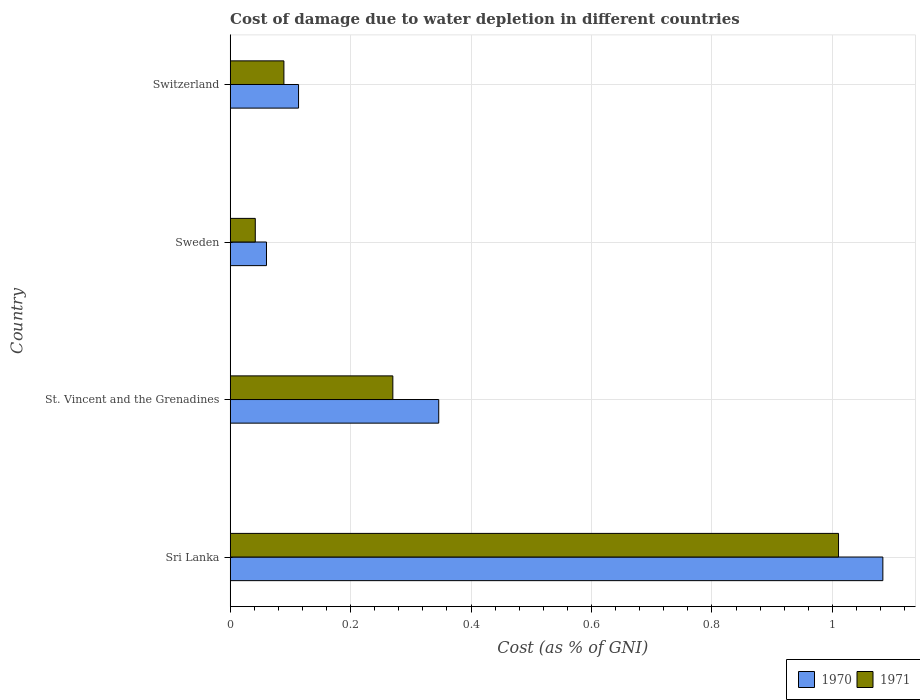How many groups of bars are there?
Offer a very short reply. 4. Are the number of bars per tick equal to the number of legend labels?
Ensure brevity in your answer.  Yes. Are the number of bars on each tick of the Y-axis equal?
Ensure brevity in your answer.  Yes. How many bars are there on the 2nd tick from the top?
Your answer should be very brief. 2. What is the label of the 4th group of bars from the top?
Your answer should be very brief. Sri Lanka. In how many cases, is the number of bars for a given country not equal to the number of legend labels?
Ensure brevity in your answer.  0. What is the cost of damage caused due to water depletion in 1971 in Sweden?
Your response must be concise. 0.04. Across all countries, what is the maximum cost of damage caused due to water depletion in 1970?
Give a very brief answer. 1.08. Across all countries, what is the minimum cost of damage caused due to water depletion in 1971?
Provide a short and direct response. 0.04. In which country was the cost of damage caused due to water depletion in 1970 maximum?
Keep it short and to the point. Sri Lanka. In which country was the cost of damage caused due to water depletion in 1971 minimum?
Make the answer very short. Sweden. What is the total cost of damage caused due to water depletion in 1970 in the graph?
Your response must be concise. 1.6. What is the difference between the cost of damage caused due to water depletion in 1971 in St. Vincent and the Grenadines and that in Switzerland?
Keep it short and to the point. 0.18. What is the difference between the cost of damage caused due to water depletion in 1970 in Switzerland and the cost of damage caused due to water depletion in 1971 in Sweden?
Give a very brief answer. 0.07. What is the average cost of damage caused due to water depletion in 1971 per country?
Your answer should be compact. 0.35. What is the difference between the cost of damage caused due to water depletion in 1970 and cost of damage caused due to water depletion in 1971 in Sweden?
Ensure brevity in your answer.  0.02. What is the ratio of the cost of damage caused due to water depletion in 1971 in Sri Lanka to that in Sweden?
Offer a terse response. 24.24. Is the cost of damage caused due to water depletion in 1971 in Sri Lanka less than that in Switzerland?
Offer a terse response. No. Is the difference between the cost of damage caused due to water depletion in 1970 in Sri Lanka and St. Vincent and the Grenadines greater than the difference between the cost of damage caused due to water depletion in 1971 in Sri Lanka and St. Vincent and the Grenadines?
Provide a succinct answer. No. What is the difference between the highest and the second highest cost of damage caused due to water depletion in 1970?
Give a very brief answer. 0.74. What is the difference between the highest and the lowest cost of damage caused due to water depletion in 1971?
Provide a short and direct response. 0.97. In how many countries, is the cost of damage caused due to water depletion in 1970 greater than the average cost of damage caused due to water depletion in 1970 taken over all countries?
Your answer should be very brief. 1. Is the sum of the cost of damage caused due to water depletion in 1970 in Sweden and Switzerland greater than the maximum cost of damage caused due to water depletion in 1971 across all countries?
Make the answer very short. No. What does the 1st bar from the top in Sweden represents?
Provide a succinct answer. 1971. How many bars are there?
Provide a succinct answer. 8. How many countries are there in the graph?
Your answer should be very brief. 4. What is the difference between two consecutive major ticks on the X-axis?
Keep it short and to the point. 0.2. Are the values on the major ticks of X-axis written in scientific E-notation?
Your answer should be compact. No. Does the graph contain grids?
Keep it short and to the point. Yes. How many legend labels are there?
Your response must be concise. 2. How are the legend labels stacked?
Make the answer very short. Horizontal. What is the title of the graph?
Keep it short and to the point. Cost of damage due to water depletion in different countries. Does "1972" appear as one of the legend labels in the graph?
Provide a short and direct response. No. What is the label or title of the X-axis?
Your answer should be very brief. Cost (as % of GNI). What is the label or title of the Y-axis?
Give a very brief answer. Country. What is the Cost (as % of GNI) in 1970 in Sri Lanka?
Offer a terse response. 1.08. What is the Cost (as % of GNI) of 1971 in Sri Lanka?
Your answer should be compact. 1.01. What is the Cost (as % of GNI) in 1970 in St. Vincent and the Grenadines?
Offer a terse response. 0.35. What is the Cost (as % of GNI) in 1971 in St. Vincent and the Grenadines?
Your answer should be compact. 0.27. What is the Cost (as % of GNI) in 1970 in Sweden?
Keep it short and to the point. 0.06. What is the Cost (as % of GNI) of 1971 in Sweden?
Give a very brief answer. 0.04. What is the Cost (as % of GNI) in 1970 in Switzerland?
Offer a very short reply. 0.11. What is the Cost (as % of GNI) in 1971 in Switzerland?
Your answer should be very brief. 0.09. Across all countries, what is the maximum Cost (as % of GNI) in 1970?
Make the answer very short. 1.08. Across all countries, what is the maximum Cost (as % of GNI) in 1971?
Your answer should be compact. 1.01. Across all countries, what is the minimum Cost (as % of GNI) in 1970?
Provide a short and direct response. 0.06. Across all countries, what is the minimum Cost (as % of GNI) of 1971?
Your response must be concise. 0.04. What is the total Cost (as % of GNI) of 1970 in the graph?
Your answer should be very brief. 1.6. What is the total Cost (as % of GNI) in 1971 in the graph?
Offer a terse response. 1.41. What is the difference between the Cost (as % of GNI) of 1970 in Sri Lanka and that in St. Vincent and the Grenadines?
Give a very brief answer. 0.74. What is the difference between the Cost (as % of GNI) of 1971 in Sri Lanka and that in St. Vincent and the Grenadines?
Give a very brief answer. 0.74. What is the difference between the Cost (as % of GNI) in 1970 in Sri Lanka and that in Sweden?
Ensure brevity in your answer.  1.02. What is the difference between the Cost (as % of GNI) of 1971 in Sri Lanka and that in Sweden?
Make the answer very short. 0.97. What is the difference between the Cost (as % of GNI) in 1970 in Sri Lanka and that in Switzerland?
Your response must be concise. 0.97. What is the difference between the Cost (as % of GNI) of 1971 in Sri Lanka and that in Switzerland?
Give a very brief answer. 0.92. What is the difference between the Cost (as % of GNI) of 1970 in St. Vincent and the Grenadines and that in Sweden?
Ensure brevity in your answer.  0.29. What is the difference between the Cost (as % of GNI) of 1971 in St. Vincent and the Grenadines and that in Sweden?
Your response must be concise. 0.23. What is the difference between the Cost (as % of GNI) in 1970 in St. Vincent and the Grenadines and that in Switzerland?
Give a very brief answer. 0.23. What is the difference between the Cost (as % of GNI) in 1971 in St. Vincent and the Grenadines and that in Switzerland?
Keep it short and to the point. 0.18. What is the difference between the Cost (as % of GNI) in 1970 in Sweden and that in Switzerland?
Your answer should be very brief. -0.05. What is the difference between the Cost (as % of GNI) in 1971 in Sweden and that in Switzerland?
Your response must be concise. -0.05. What is the difference between the Cost (as % of GNI) of 1970 in Sri Lanka and the Cost (as % of GNI) of 1971 in St. Vincent and the Grenadines?
Your response must be concise. 0.81. What is the difference between the Cost (as % of GNI) of 1970 in Sri Lanka and the Cost (as % of GNI) of 1971 in Sweden?
Offer a very short reply. 1.04. What is the difference between the Cost (as % of GNI) in 1970 in Sri Lanka and the Cost (as % of GNI) in 1971 in Switzerland?
Provide a short and direct response. 0.99. What is the difference between the Cost (as % of GNI) in 1970 in St. Vincent and the Grenadines and the Cost (as % of GNI) in 1971 in Sweden?
Keep it short and to the point. 0.3. What is the difference between the Cost (as % of GNI) in 1970 in St. Vincent and the Grenadines and the Cost (as % of GNI) in 1971 in Switzerland?
Keep it short and to the point. 0.26. What is the difference between the Cost (as % of GNI) in 1970 in Sweden and the Cost (as % of GNI) in 1971 in Switzerland?
Offer a very short reply. -0.03. What is the average Cost (as % of GNI) in 1970 per country?
Keep it short and to the point. 0.4. What is the average Cost (as % of GNI) in 1971 per country?
Give a very brief answer. 0.35. What is the difference between the Cost (as % of GNI) in 1970 and Cost (as % of GNI) in 1971 in Sri Lanka?
Offer a terse response. 0.07. What is the difference between the Cost (as % of GNI) in 1970 and Cost (as % of GNI) in 1971 in St. Vincent and the Grenadines?
Provide a short and direct response. 0.08. What is the difference between the Cost (as % of GNI) in 1970 and Cost (as % of GNI) in 1971 in Sweden?
Ensure brevity in your answer.  0.02. What is the difference between the Cost (as % of GNI) in 1970 and Cost (as % of GNI) in 1971 in Switzerland?
Ensure brevity in your answer.  0.02. What is the ratio of the Cost (as % of GNI) in 1970 in Sri Lanka to that in St. Vincent and the Grenadines?
Make the answer very short. 3.13. What is the ratio of the Cost (as % of GNI) of 1971 in Sri Lanka to that in St. Vincent and the Grenadines?
Make the answer very short. 3.74. What is the ratio of the Cost (as % of GNI) of 1970 in Sri Lanka to that in Sweden?
Your answer should be very brief. 17.98. What is the ratio of the Cost (as % of GNI) of 1971 in Sri Lanka to that in Sweden?
Provide a succinct answer. 24.24. What is the ratio of the Cost (as % of GNI) in 1970 in Sri Lanka to that in Switzerland?
Your answer should be compact. 9.55. What is the ratio of the Cost (as % of GNI) of 1971 in Sri Lanka to that in Switzerland?
Give a very brief answer. 11.33. What is the ratio of the Cost (as % of GNI) in 1970 in St. Vincent and the Grenadines to that in Sweden?
Provide a succinct answer. 5.75. What is the ratio of the Cost (as % of GNI) in 1971 in St. Vincent and the Grenadines to that in Sweden?
Offer a very short reply. 6.48. What is the ratio of the Cost (as % of GNI) of 1970 in St. Vincent and the Grenadines to that in Switzerland?
Make the answer very short. 3.05. What is the ratio of the Cost (as % of GNI) in 1971 in St. Vincent and the Grenadines to that in Switzerland?
Your answer should be very brief. 3.03. What is the ratio of the Cost (as % of GNI) of 1970 in Sweden to that in Switzerland?
Provide a succinct answer. 0.53. What is the ratio of the Cost (as % of GNI) of 1971 in Sweden to that in Switzerland?
Your answer should be compact. 0.47. What is the difference between the highest and the second highest Cost (as % of GNI) in 1970?
Give a very brief answer. 0.74. What is the difference between the highest and the second highest Cost (as % of GNI) in 1971?
Ensure brevity in your answer.  0.74. What is the difference between the highest and the lowest Cost (as % of GNI) of 1970?
Offer a very short reply. 1.02. What is the difference between the highest and the lowest Cost (as % of GNI) of 1971?
Give a very brief answer. 0.97. 